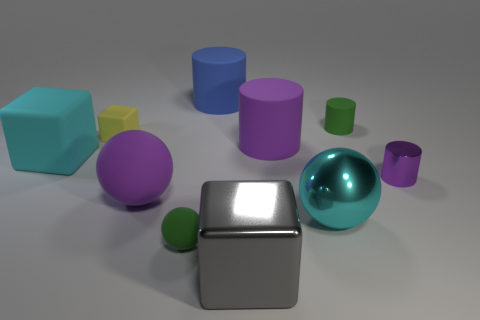Subtract all rubber cylinders. How many cylinders are left? 1 Subtract all blue cylinders. How many cylinders are left? 3 Subtract all cylinders. How many objects are left? 6 Subtract 3 cylinders. How many cylinders are left? 1 Subtract all brown blocks. Subtract all purple cylinders. How many blocks are left? 3 Subtract all gray balls. How many yellow cubes are left? 1 Subtract all tiny matte blocks. Subtract all tiny green cylinders. How many objects are left? 8 Add 9 yellow rubber blocks. How many yellow rubber blocks are left? 10 Add 9 cyan cubes. How many cyan cubes exist? 10 Subtract 1 cyan balls. How many objects are left? 9 